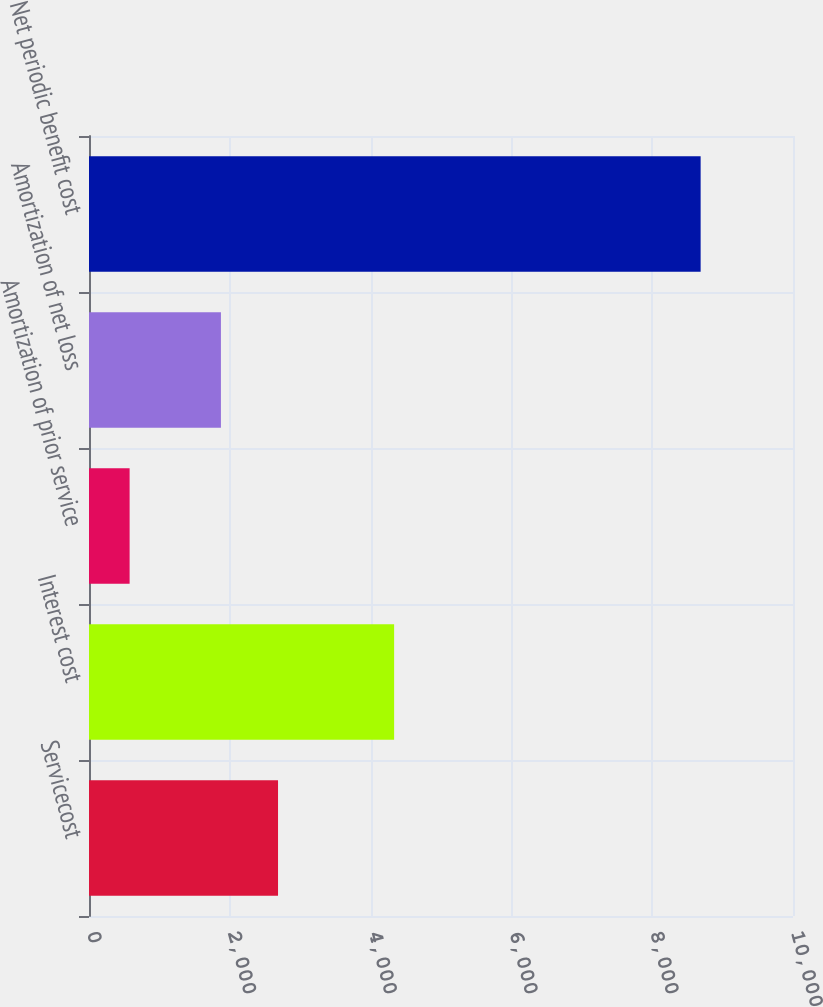<chart> <loc_0><loc_0><loc_500><loc_500><bar_chart><fcel>Servicecost<fcel>Interest cost<fcel>Amortization of prior service<fcel>Amortization of net loss<fcel>Net periodic benefit cost<nl><fcel>2685.1<fcel>4334<fcel>577<fcel>1874<fcel>8688<nl></chart> 